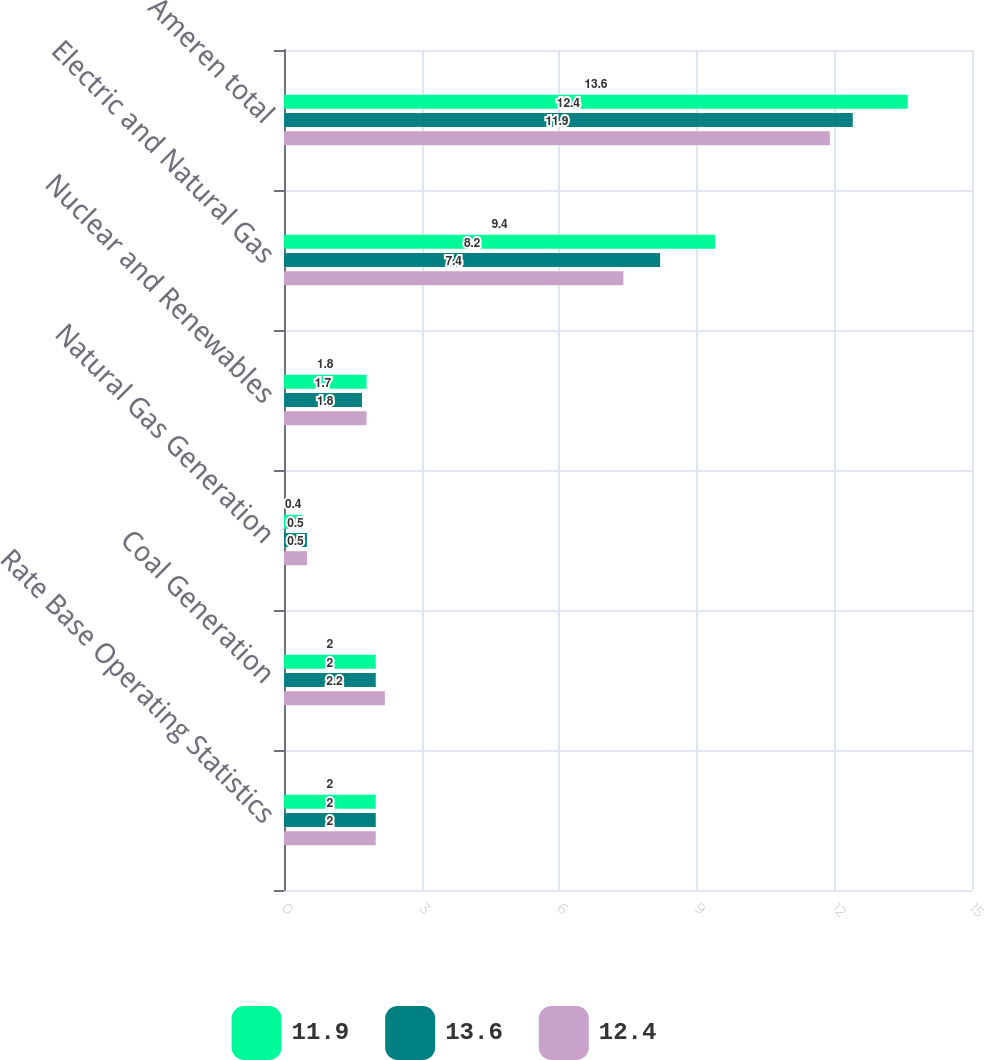<chart> <loc_0><loc_0><loc_500><loc_500><stacked_bar_chart><ecel><fcel>Rate Base Operating Statistics<fcel>Coal Generation<fcel>Natural Gas Generation<fcel>Nuclear and Renewables<fcel>Electric and Natural Gas<fcel>Ameren total<nl><fcel>11.9<fcel>2<fcel>2<fcel>0.4<fcel>1.8<fcel>9.4<fcel>13.6<nl><fcel>13.6<fcel>2<fcel>2<fcel>0.5<fcel>1.7<fcel>8.2<fcel>12.4<nl><fcel>12.4<fcel>2<fcel>2.2<fcel>0.5<fcel>1.8<fcel>7.4<fcel>11.9<nl></chart> 